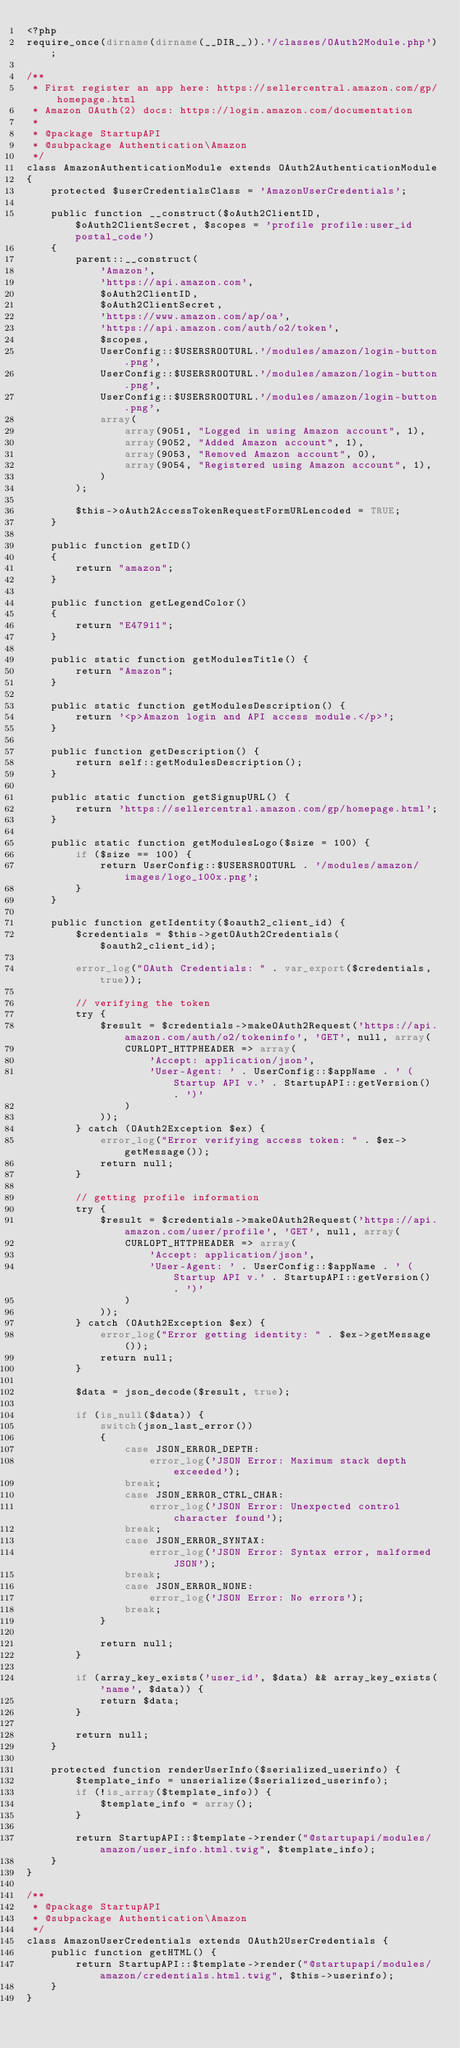<code> <loc_0><loc_0><loc_500><loc_500><_PHP_><?php
require_once(dirname(dirname(__DIR__)).'/classes/OAuth2Module.php');

/**
 * First register an app here: https://sellercentral.amazon.com/gp/homepage.html
 * Amazon OAuth(2) docs: https://login.amazon.com/documentation
 *
 * @package StartupAPI
 * @subpackage Authentication\Amazon
 */
class AmazonAuthenticationModule extends OAuth2AuthenticationModule
{
	protected $userCredentialsClass = 'AmazonUserCredentials';

	public function __construct($oAuth2ClientID, $oAuth2ClientSecret, $scopes = 'profile profile:user_id postal_code')
	{
		parent::__construct(
			'Amazon',
			'https://api.amazon.com',
			$oAuth2ClientID,
			$oAuth2ClientSecret,
			'https://www.amazon.com/ap/oa',
			'https://api.amazon.com/auth/o2/token',
			$scopes,
			UserConfig::$USERSROOTURL.'/modules/amazon/login-button.png',
			UserConfig::$USERSROOTURL.'/modules/amazon/login-button.png',
			UserConfig::$USERSROOTURL.'/modules/amazon/login-button.png',
			array(
				array(9051, "Logged in using Amazon account", 1),
				array(9052, "Added Amazon account", 1),
				array(9053, "Removed Amazon account", 0),
				array(9054, "Registered using Amazon account", 1),
			)
		);

		$this->oAuth2AccessTokenRequestFormURLencoded = TRUE;
	}

	public function getID()
	{
		return "amazon";
	}

	public function getLegendColor()
	{
		return "E47911";
	}

	public static function getModulesTitle() {
		return "Amazon";
	}

	public static function getModulesDescription() {
		return '<p>Amazon login and API access module.</p>';
	}

	public function getDescription() {
		return self::getModulesDescription();
	}

	public static function getSignupURL() {
		return 'https://sellercentral.amazon.com/gp/homepage.html';
	}

	public static function getModulesLogo($size = 100) {
		if ($size == 100) {
			return UserConfig::$USERSROOTURL . '/modules/amazon/images/logo_100x.png';
		}
	}

	public function getIdentity($oauth2_client_id) {
		$credentials = $this->getOAuth2Credentials($oauth2_client_id);

		error_log("OAuth Credentials: " . var_export($credentials, true));

		// verifying the token
		try {
			$result = $credentials->makeOAuth2Request('https://api.amazon.com/auth/o2/tokeninfo', 'GET', null, array(
				CURLOPT_HTTPHEADER => array(
					'Accept: application/json',
					'User-Agent: ' . UserConfig::$appName . ' (Startup API v.' . StartupAPI::getVersion() . ')'
				)
			));
		} catch (OAuth2Exception $ex) {
			error_log("Error verifying access token: " . $ex->getMessage());
			return null;
		}

		// getting profile information
		try {
			$result = $credentials->makeOAuth2Request('https://api.amazon.com/user/profile', 'GET', null, array(
				CURLOPT_HTTPHEADER => array(
					'Accept: application/json',
					'User-Agent: ' . UserConfig::$appName . ' (Startup API v.' . StartupAPI::getVersion() . ')'
				)
			));
		} catch (OAuth2Exception $ex) {
			error_log("Error getting identity: " . $ex->getMessage());
			return null;
		}

		$data = json_decode($result, true);

		if (is_null($data)) {
			switch(json_last_error())
			{
				case JSON_ERROR_DEPTH:
					error_log('JSON Error: Maximum stack depth exceeded');
				break;
				case JSON_ERROR_CTRL_CHAR:
					error_log('JSON Error: Unexpected control character found');
				break;
				case JSON_ERROR_SYNTAX:
					error_log('JSON Error: Syntax error, malformed JSON');
				break;
				case JSON_ERROR_NONE:
					error_log('JSON Error: No errors');
				break;
			}

			return null;
		}

		if (array_key_exists('user_id', $data) && array_key_exists('name', $data)) {
			return $data;
		}

		return null;
	}

	protected function renderUserInfo($serialized_userinfo) {
		$template_info = unserialize($serialized_userinfo);
		if (!is_array($template_info)) {
			$template_info = array();
		}

		return StartupAPI::$template->render("@startupapi/modules/amazon/user_info.html.twig", $template_info);
	}
}

/**
 * @package StartupAPI
 * @subpackage Authentication\Amazon
 */
class AmazonUserCredentials extends OAuth2UserCredentials {
	public function getHTML() {
		return StartupAPI::$template->render("@startupapi/modules/amazon/credentials.html.twig", $this->userinfo);
	}
}
</code> 